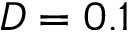Convert formula to latex. <formula><loc_0><loc_0><loc_500><loc_500>D = 0 . 1</formula> 